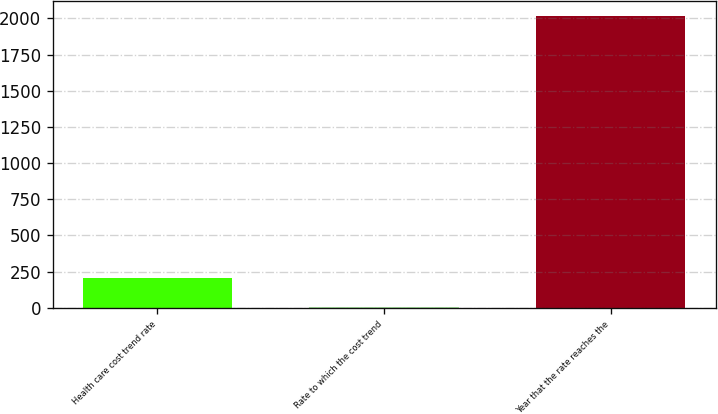<chart> <loc_0><loc_0><loc_500><loc_500><bar_chart><fcel>Health care cost trend rate<fcel>Rate to which the cost trend<fcel>Year that the rate reaches the<nl><fcel>205.75<fcel>4.5<fcel>2017<nl></chart> 